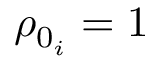<formula> <loc_0><loc_0><loc_500><loc_500>\rho _ { 0 _ { i } } = 1</formula> 